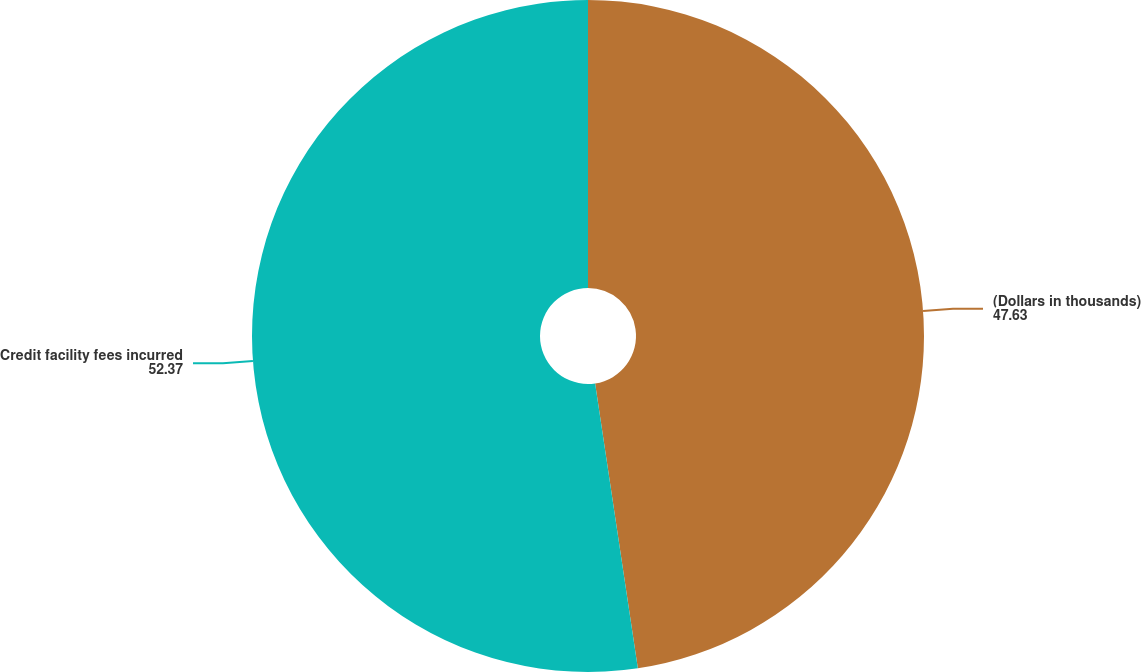Convert chart to OTSL. <chart><loc_0><loc_0><loc_500><loc_500><pie_chart><fcel>(Dollars in thousands)<fcel>Credit facility fees incurred<nl><fcel>47.63%<fcel>52.37%<nl></chart> 